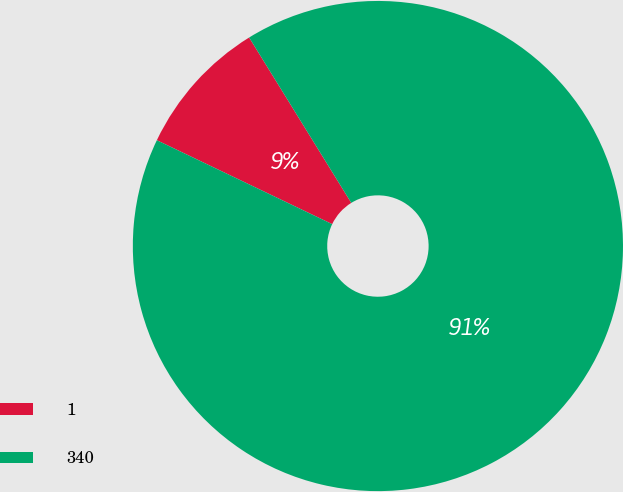Convert chart. <chart><loc_0><loc_0><loc_500><loc_500><pie_chart><fcel>1<fcel>340<nl><fcel>9.09%<fcel>90.91%<nl></chart> 